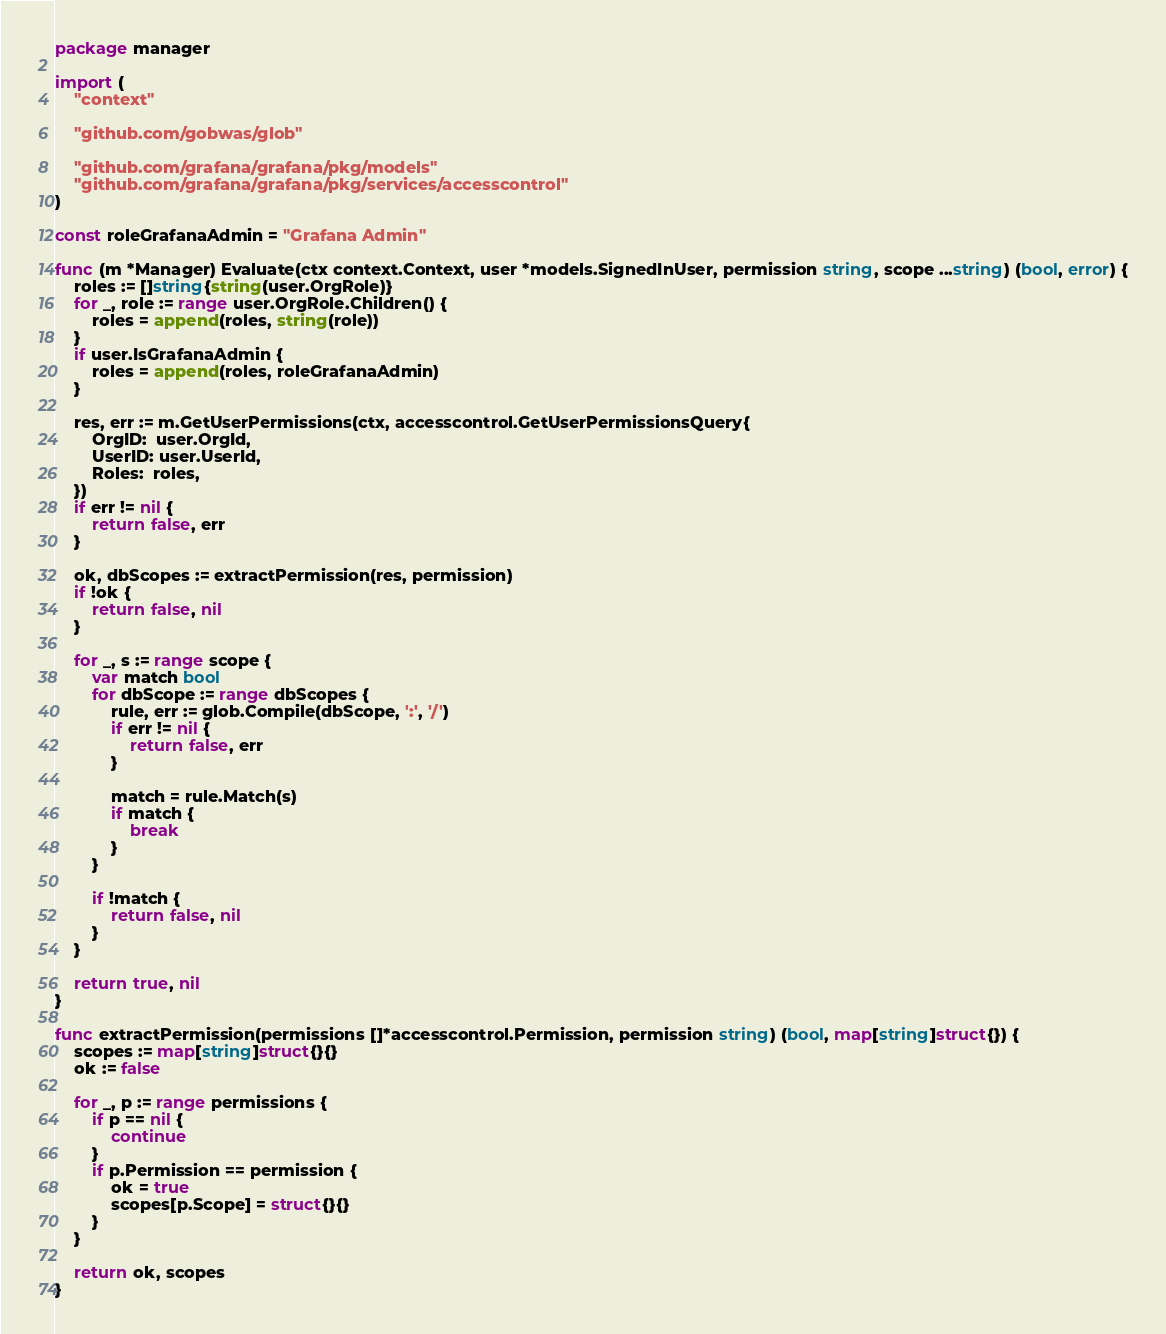<code> <loc_0><loc_0><loc_500><loc_500><_Go_>package manager

import (
	"context"

	"github.com/gobwas/glob"

	"github.com/grafana/grafana/pkg/models"
	"github.com/grafana/grafana/pkg/services/accesscontrol"
)

const roleGrafanaAdmin = "Grafana Admin"

func (m *Manager) Evaluate(ctx context.Context, user *models.SignedInUser, permission string, scope ...string) (bool, error) {
	roles := []string{string(user.OrgRole)}
	for _, role := range user.OrgRole.Children() {
		roles = append(roles, string(role))
	}
	if user.IsGrafanaAdmin {
		roles = append(roles, roleGrafanaAdmin)
	}

	res, err := m.GetUserPermissions(ctx, accesscontrol.GetUserPermissionsQuery{
		OrgID:  user.OrgId,
		UserID: user.UserId,
		Roles:  roles,
	})
	if err != nil {
		return false, err
	}

	ok, dbScopes := extractPermission(res, permission)
	if !ok {
		return false, nil
	}

	for _, s := range scope {
		var match bool
		for dbScope := range dbScopes {
			rule, err := glob.Compile(dbScope, ':', '/')
			if err != nil {
				return false, err
			}

			match = rule.Match(s)
			if match {
				break
			}
		}

		if !match {
			return false, nil
		}
	}

	return true, nil
}

func extractPermission(permissions []*accesscontrol.Permission, permission string) (bool, map[string]struct{}) {
	scopes := map[string]struct{}{}
	ok := false

	for _, p := range permissions {
		if p == nil {
			continue
		}
		if p.Permission == permission {
			ok = true
			scopes[p.Scope] = struct{}{}
		}
	}

	return ok, scopes
}
</code> 